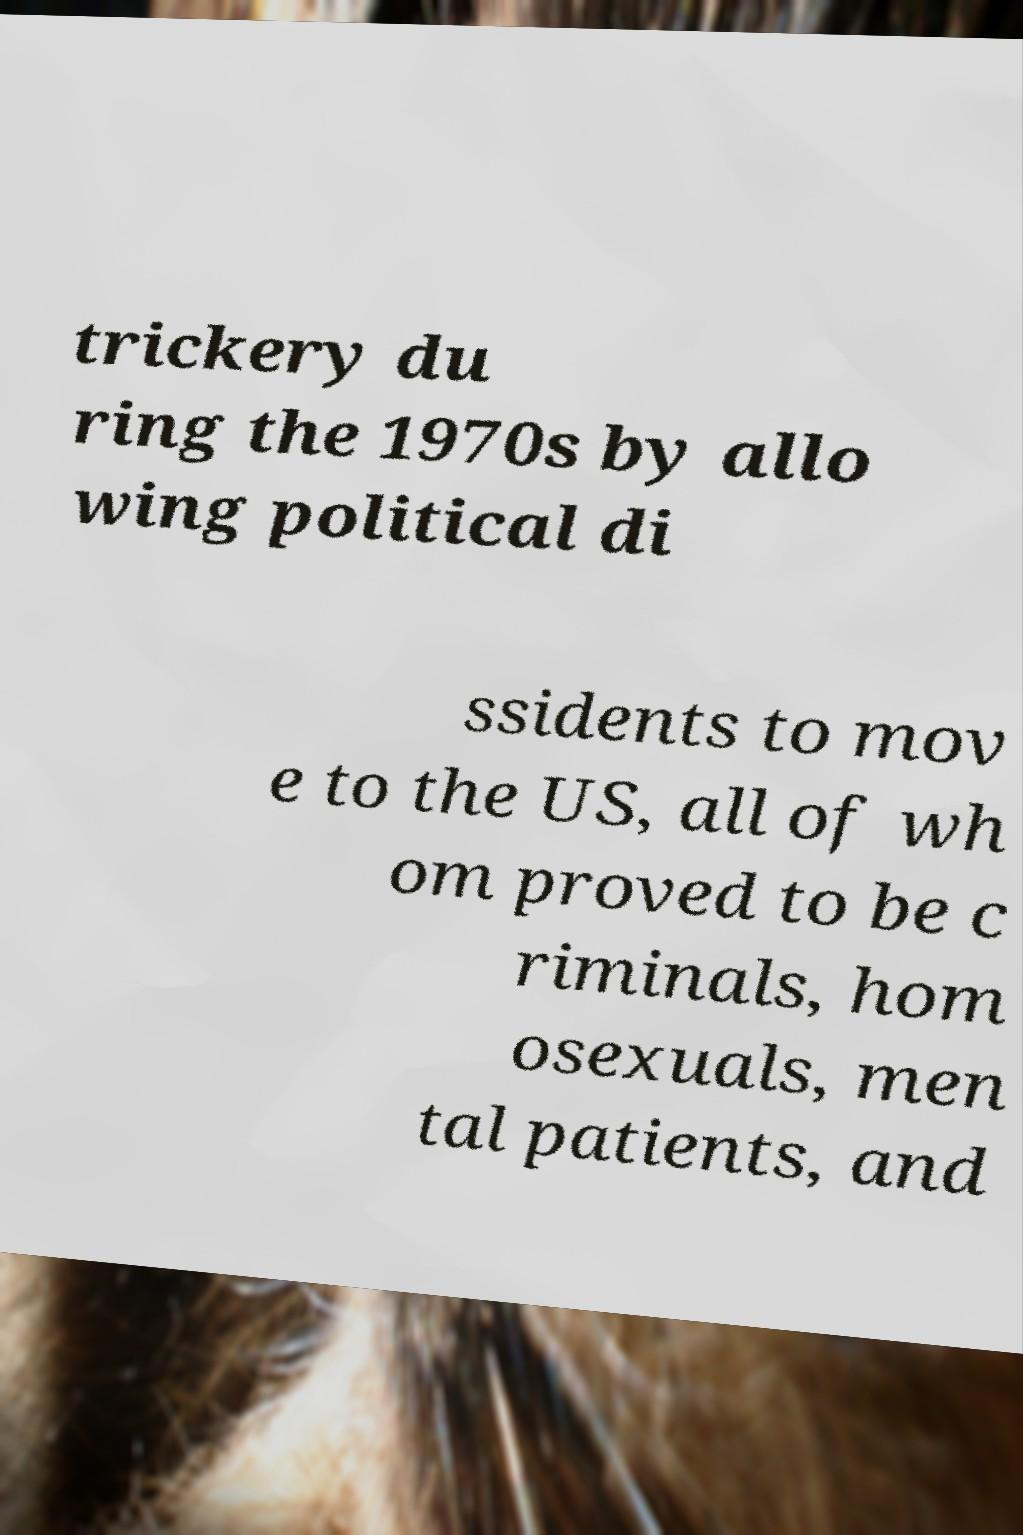Can you read and provide the text displayed in the image?This photo seems to have some interesting text. Can you extract and type it out for me? trickery du ring the 1970s by allo wing political di ssidents to mov e to the US, all of wh om proved to be c riminals, hom osexuals, men tal patients, and 